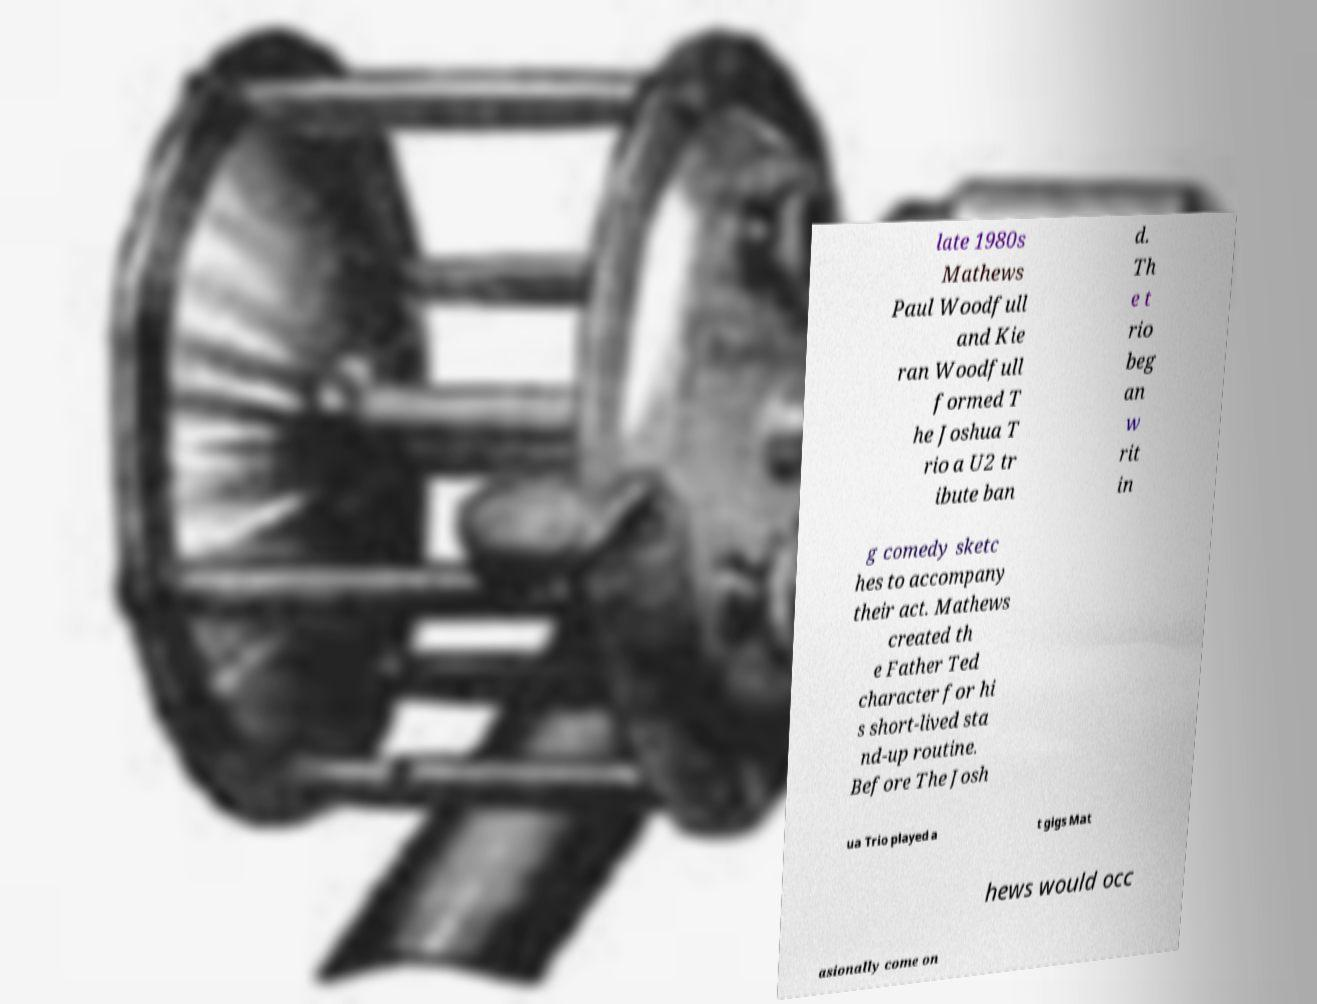There's text embedded in this image that I need extracted. Can you transcribe it verbatim? late 1980s Mathews Paul Woodfull and Kie ran Woodfull formed T he Joshua T rio a U2 tr ibute ban d. Th e t rio beg an w rit in g comedy sketc hes to accompany their act. Mathews created th e Father Ted character for hi s short-lived sta nd-up routine. Before The Josh ua Trio played a t gigs Mat hews would occ asionally come on 